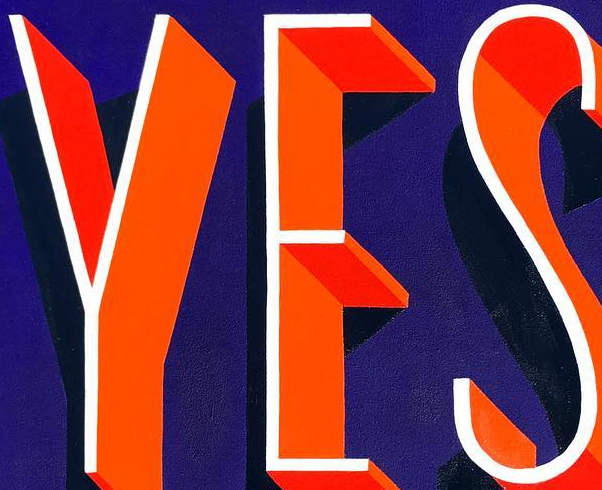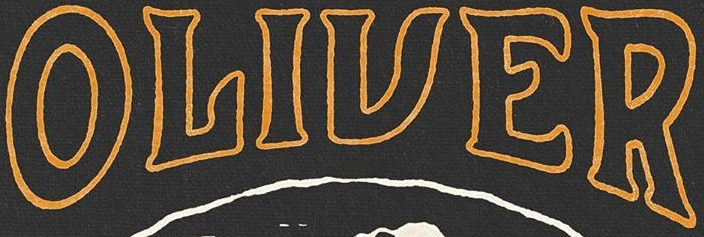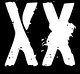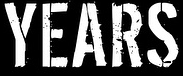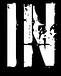What words are shown in these images in order, separated by a semicolon? YES; OLIVER; XX; YEARS; IN 